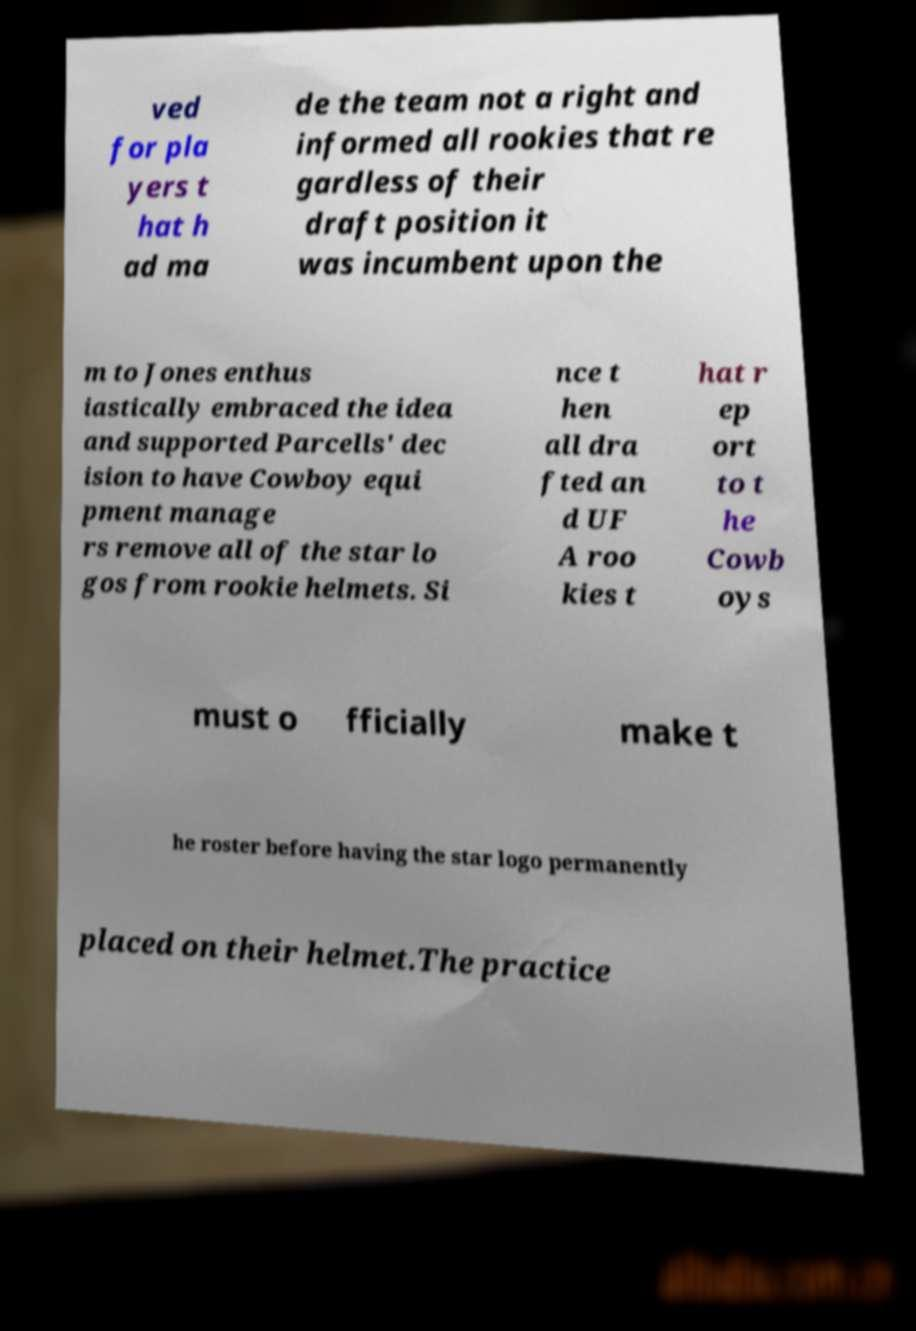Please read and relay the text visible in this image. What does it say? ved for pla yers t hat h ad ma de the team not a right and informed all rookies that re gardless of their draft position it was incumbent upon the m to Jones enthus iastically embraced the idea and supported Parcells' dec ision to have Cowboy equi pment manage rs remove all of the star lo gos from rookie helmets. Si nce t hen all dra fted an d UF A roo kies t hat r ep ort to t he Cowb oys must o fficially make t he roster before having the star logo permanently placed on their helmet.The practice 